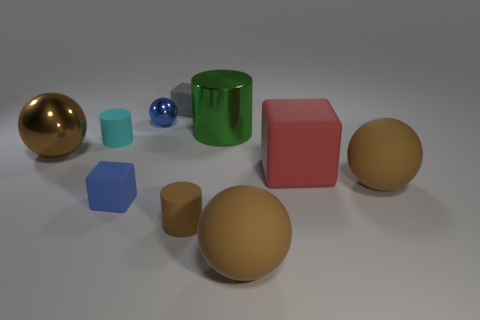Does the large green object have the same material as the red thing?
Ensure brevity in your answer.  No. What shape is the brown object that is behind the tiny blue matte object and right of the green shiny thing?
Ensure brevity in your answer.  Sphere. What is the size of the brown thing that is left of the matte cylinder that is to the left of the tiny brown matte cylinder?
Your answer should be very brief. Large. What number of tiny objects have the same color as the big metallic sphere?
Your answer should be very brief. 1. What number of other objects are the same size as the blue ball?
Offer a very short reply. 4. What size is the ball that is both on the right side of the tiny metal object and on the left side of the large red object?
Your response must be concise. Large. What number of tiny brown objects are the same shape as the big green object?
Offer a very short reply. 1. What is the blue block made of?
Your answer should be very brief. Rubber. Is the large red matte thing the same shape as the gray object?
Provide a short and direct response. Yes. Are there any large red cylinders made of the same material as the cyan cylinder?
Provide a short and direct response. No. 